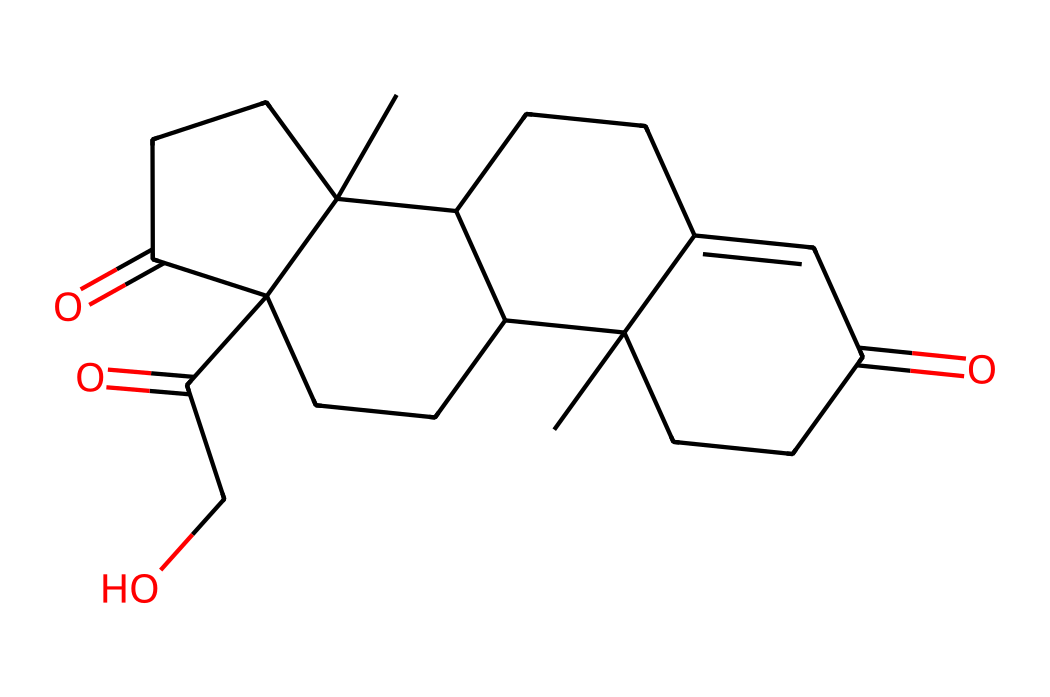how many carbon atoms are present in cortisol? Analyzing the SMILES representation, we count the number of 'C' symbols, which represent carbon atoms. In the provided SMILES, there are 21 'C' characters, indicating 21 carbon atoms in cortisol.
Answer: 21 what is the molecular formula for cortisol? The molecular formula can be derived from the counts of each type of atom in the SMILES representation: 21 carbons (C), 30 hydrogens (H), and 5 oxygens (O). Thus, the molecular formula is C21H30O5.
Answer: C21H30O5 what functional groups are present in cortisol? In the given structure, we can identify ketone groups (C=O) and hydroxyl groups (C-OH). The presence of these groups indicates that cortisol has both a steroid structure and functional groups associated with its activity.
Answer: ketone, hydroxyl how many rings are in the structure of cortisol? By visualizing the SMILES representation, we identify multiple cyclic structures (indicated by numbers in the SMILES). Counting these, we find that cortisol has four rings in its structure.
Answer: 4 what type of hormone is cortisol classified as? Given that cortisol is derived from cholesterol and functions in stress response, it is classified as a steroid hormone. Its structure supports this classification, as it contains multiple rings characteristic of steroids.
Answer: steroid what role does cortisol play in the human body? Cortisol primarily acts to regulate metabolism, reduce inflammation, and control the body's stress response. This information relates to its function rather than its structure, but it is critical to understanding cortisol's importance.
Answer: stress response how does the structure of cortisol relate to its biological function? The complex multi-ring structure of cortisol allows it to interact effectively with cellular receptors. This specific arrangement is pivotal for its role in regulating various physiological processes, including metabolism and immune response.
Answer: receptor interaction 